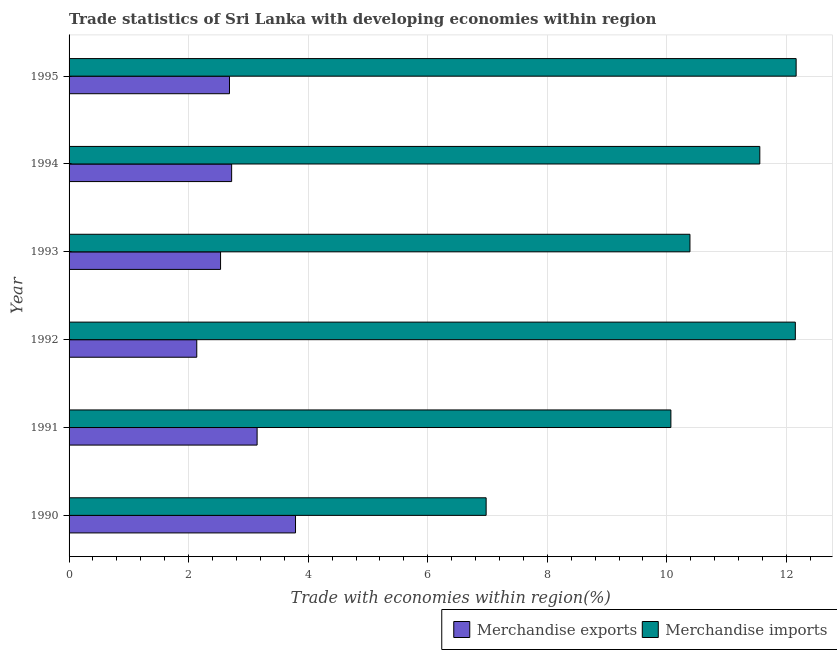How many different coloured bars are there?
Your response must be concise. 2. Are the number of bars per tick equal to the number of legend labels?
Ensure brevity in your answer.  Yes. How many bars are there on the 1st tick from the bottom?
Ensure brevity in your answer.  2. In how many cases, is the number of bars for a given year not equal to the number of legend labels?
Ensure brevity in your answer.  0. What is the merchandise imports in 1991?
Your answer should be compact. 10.07. Across all years, what is the maximum merchandise exports?
Offer a very short reply. 3.79. Across all years, what is the minimum merchandise exports?
Provide a succinct answer. 2.14. In which year was the merchandise exports maximum?
Your answer should be compact. 1990. What is the total merchandise exports in the graph?
Your answer should be very brief. 17.01. What is the difference between the merchandise imports in 1994 and that in 1995?
Your answer should be very brief. -0.61. What is the difference between the merchandise exports in 1992 and the merchandise imports in 1995?
Ensure brevity in your answer.  -10.03. What is the average merchandise exports per year?
Offer a terse response. 2.83. In the year 1993, what is the difference between the merchandise exports and merchandise imports?
Your answer should be very brief. -7.85. In how many years, is the merchandise imports greater than 7.6 %?
Your answer should be very brief. 5. What is the ratio of the merchandise exports in 1990 to that in 1993?
Your response must be concise. 1.5. Is the difference between the merchandise exports in 1990 and 1994 greater than the difference between the merchandise imports in 1990 and 1994?
Offer a very short reply. Yes. What is the difference between the highest and the second highest merchandise exports?
Provide a succinct answer. 0.64. What is the difference between the highest and the lowest merchandise exports?
Keep it short and to the point. 1.65. What does the 2nd bar from the top in 1992 represents?
Your answer should be compact. Merchandise exports. What does the 2nd bar from the bottom in 1992 represents?
Give a very brief answer. Merchandise imports. Are all the bars in the graph horizontal?
Offer a very short reply. Yes. Does the graph contain any zero values?
Your answer should be very brief. No. Does the graph contain grids?
Offer a very short reply. Yes. How many legend labels are there?
Your response must be concise. 2. How are the legend labels stacked?
Offer a terse response. Horizontal. What is the title of the graph?
Provide a succinct answer. Trade statistics of Sri Lanka with developing economies within region. What is the label or title of the X-axis?
Keep it short and to the point. Trade with economies within region(%). What is the Trade with economies within region(%) of Merchandise exports in 1990?
Your answer should be compact. 3.79. What is the Trade with economies within region(%) in Merchandise imports in 1990?
Provide a short and direct response. 6.98. What is the Trade with economies within region(%) in Merchandise exports in 1991?
Provide a short and direct response. 3.15. What is the Trade with economies within region(%) of Merchandise imports in 1991?
Offer a very short reply. 10.07. What is the Trade with economies within region(%) of Merchandise exports in 1992?
Ensure brevity in your answer.  2.14. What is the Trade with economies within region(%) of Merchandise imports in 1992?
Your answer should be compact. 12.15. What is the Trade with economies within region(%) of Merchandise exports in 1993?
Give a very brief answer. 2.53. What is the Trade with economies within region(%) of Merchandise imports in 1993?
Your answer should be compact. 10.39. What is the Trade with economies within region(%) in Merchandise exports in 1994?
Your answer should be compact. 2.72. What is the Trade with economies within region(%) of Merchandise imports in 1994?
Make the answer very short. 11.55. What is the Trade with economies within region(%) of Merchandise exports in 1995?
Provide a short and direct response. 2.68. What is the Trade with economies within region(%) of Merchandise imports in 1995?
Offer a terse response. 12.16. Across all years, what is the maximum Trade with economies within region(%) in Merchandise exports?
Provide a succinct answer. 3.79. Across all years, what is the maximum Trade with economies within region(%) in Merchandise imports?
Your response must be concise. 12.16. Across all years, what is the minimum Trade with economies within region(%) in Merchandise exports?
Give a very brief answer. 2.14. Across all years, what is the minimum Trade with economies within region(%) in Merchandise imports?
Provide a succinct answer. 6.98. What is the total Trade with economies within region(%) of Merchandise exports in the graph?
Make the answer very short. 17.01. What is the total Trade with economies within region(%) of Merchandise imports in the graph?
Provide a succinct answer. 63.3. What is the difference between the Trade with economies within region(%) in Merchandise exports in 1990 and that in 1991?
Your response must be concise. 0.64. What is the difference between the Trade with economies within region(%) in Merchandise imports in 1990 and that in 1991?
Keep it short and to the point. -3.09. What is the difference between the Trade with economies within region(%) of Merchandise exports in 1990 and that in 1992?
Ensure brevity in your answer.  1.65. What is the difference between the Trade with economies within region(%) in Merchandise imports in 1990 and that in 1992?
Your answer should be very brief. -5.17. What is the difference between the Trade with economies within region(%) in Merchandise exports in 1990 and that in 1993?
Ensure brevity in your answer.  1.25. What is the difference between the Trade with economies within region(%) in Merchandise imports in 1990 and that in 1993?
Offer a very short reply. -3.41. What is the difference between the Trade with economies within region(%) of Merchandise exports in 1990 and that in 1994?
Your answer should be very brief. 1.07. What is the difference between the Trade with economies within region(%) of Merchandise imports in 1990 and that in 1994?
Offer a terse response. -4.58. What is the difference between the Trade with economies within region(%) of Merchandise exports in 1990 and that in 1995?
Offer a terse response. 1.1. What is the difference between the Trade with economies within region(%) of Merchandise imports in 1990 and that in 1995?
Offer a very short reply. -5.19. What is the difference between the Trade with economies within region(%) in Merchandise exports in 1991 and that in 1992?
Offer a terse response. 1.01. What is the difference between the Trade with economies within region(%) of Merchandise imports in 1991 and that in 1992?
Provide a succinct answer. -2.08. What is the difference between the Trade with economies within region(%) of Merchandise exports in 1991 and that in 1993?
Offer a terse response. 0.61. What is the difference between the Trade with economies within region(%) of Merchandise imports in 1991 and that in 1993?
Your response must be concise. -0.32. What is the difference between the Trade with economies within region(%) in Merchandise exports in 1991 and that in 1994?
Your response must be concise. 0.43. What is the difference between the Trade with economies within region(%) in Merchandise imports in 1991 and that in 1994?
Keep it short and to the point. -1.49. What is the difference between the Trade with economies within region(%) in Merchandise exports in 1991 and that in 1995?
Your answer should be compact. 0.46. What is the difference between the Trade with economies within region(%) of Merchandise imports in 1991 and that in 1995?
Your answer should be very brief. -2.1. What is the difference between the Trade with economies within region(%) in Merchandise exports in 1992 and that in 1993?
Your answer should be compact. -0.4. What is the difference between the Trade with economies within region(%) in Merchandise imports in 1992 and that in 1993?
Make the answer very short. 1.76. What is the difference between the Trade with economies within region(%) in Merchandise exports in 1992 and that in 1994?
Ensure brevity in your answer.  -0.58. What is the difference between the Trade with economies within region(%) in Merchandise imports in 1992 and that in 1994?
Provide a succinct answer. 0.59. What is the difference between the Trade with economies within region(%) in Merchandise exports in 1992 and that in 1995?
Your response must be concise. -0.55. What is the difference between the Trade with economies within region(%) of Merchandise imports in 1992 and that in 1995?
Make the answer very short. -0.01. What is the difference between the Trade with economies within region(%) of Merchandise exports in 1993 and that in 1994?
Give a very brief answer. -0.19. What is the difference between the Trade with economies within region(%) in Merchandise imports in 1993 and that in 1994?
Your response must be concise. -1.17. What is the difference between the Trade with economies within region(%) in Merchandise exports in 1993 and that in 1995?
Offer a very short reply. -0.15. What is the difference between the Trade with economies within region(%) of Merchandise imports in 1993 and that in 1995?
Make the answer very short. -1.78. What is the difference between the Trade with economies within region(%) in Merchandise exports in 1994 and that in 1995?
Offer a very short reply. 0.04. What is the difference between the Trade with economies within region(%) in Merchandise imports in 1994 and that in 1995?
Ensure brevity in your answer.  -0.61. What is the difference between the Trade with economies within region(%) of Merchandise exports in 1990 and the Trade with economies within region(%) of Merchandise imports in 1991?
Offer a very short reply. -6.28. What is the difference between the Trade with economies within region(%) in Merchandise exports in 1990 and the Trade with economies within region(%) in Merchandise imports in 1992?
Give a very brief answer. -8.36. What is the difference between the Trade with economies within region(%) of Merchandise exports in 1990 and the Trade with economies within region(%) of Merchandise imports in 1993?
Provide a short and direct response. -6.6. What is the difference between the Trade with economies within region(%) in Merchandise exports in 1990 and the Trade with economies within region(%) in Merchandise imports in 1994?
Give a very brief answer. -7.77. What is the difference between the Trade with economies within region(%) of Merchandise exports in 1990 and the Trade with economies within region(%) of Merchandise imports in 1995?
Your answer should be very brief. -8.37. What is the difference between the Trade with economies within region(%) of Merchandise exports in 1991 and the Trade with economies within region(%) of Merchandise imports in 1992?
Ensure brevity in your answer.  -9. What is the difference between the Trade with economies within region(%) of Merchandise exports in 1991 and the Trade with economies within region(%) of Merchandise imports in 1993?
Ensure brevity in your answer.  -7.24. What is the difference between the Trade with economies within region(%) in Merchandise exports in 1991 and the Trade with economies within region(%) in Merchandise imports in 1994?
Offer a terse response. -8.41. What is the difference between the Trade with economies within region(%) of Merchandise exports in 1991 and the Trade with economies within region(%) of Merchandise imports in 1995?
Offer a terse response. -9.02. What is the difference between the Trade with economies within region(%) in Merchandise exports in 1992 and the Trade with economies within region(%) in Merchandise imports in 1993?
Your answer should be compact. -8.25. What is the difference between the Trade with economies within region(%) of Merchandise exports in 1992 and the Trade with economies within region(%) of Merchandise imports in 1994?
Make the answer very short. -9.42. What is the difference between the Trade with economies within region(%) in Merchandise exports in 1992 and the Trade with economies within region(%) in Merchandise imports in 1995?
Offer a very short reply. -10.03. What is the difference between the Trade with economies within region(%) of Merchandise exports in 1993 and the Trade with economies within region(%) of Merchandise imports in 1994?
Your response must be concise. -9.02. What is the difference between the Trade with economies within region(%) of Merchandise exports in 1993 and the Trade with economies within region(%) of Merchandise imports in 1995?
Offer a very short reply. -9.63. What is the difference between the Trade with economies within region(%) in Merchandise exports in 1994 and the Trade with economies within region(%) in Merchandise imports in 1995?
Keep it short and to the point. -9.44. What is the average Trade with economies within region(%) in Merchandise exports per year?
Make the answer very short. 2.83. What is the average Trade with economies within region(%) in Merchandise imports per year?
Offer a terse response. 10.55. In the year 1990, what is the difference between the Trade with economies within region(%) of Merchandise exports and Trade with economies within region(%) of Merchandise imports?
Your response must be concise. -3.19. In the year 1991, what is the difference between the Trade with economies within region(%) of Merchandise exports and Trade with economies within region(%) of Merchandise imports?
Make the answer very short. -6.92. In the year 1992, what is the difference between the Trade with economies within region(%) in Merchandise exports and Trade with economies within region(%) in Merchandise imports?
Provide a short and direct response. -10.01. In the year 1993, what is the difference between the Trade with economies within region(%) of Merchandise exports and Trade with economies within region(%) of Merchandise imports?
Ensure brevity in your answer.  -7.85. In the year 1994, what is the difference between the Trade with economies within region(%) in Merchandise exports and Trade with economies within region(%) in Merchandise imports?
Ensure brevity in your answer.  -8.84. In the year 1995, what is the difference between the Trade with economies within region(%) in Merchandise exports and Trade with economies within region(%) in Merchandise imports?
Give a very brief answer. -9.48. What is the ratio of the Trade with economies within region(%) in Merchandise exports in 1990 to that in 1991?
Make the answer very short. 1.2. What is the ratio of the Trade with economies within region(%) of Merchandise imports in 1990 to that in 1991?
Keep it short and to the point. 0.69. What is the ratio of the Trade with economies within region(%) in Merchandise exports in 1990 to that in 1992?
Offer a terse response. 1.77. What is the ratio of the Trade with economies within region(%) in Merchandise imports in 1990 to that in 1992?
Keep it short and to the point. 0.57. What is the ratio of the Trade with economies within region(%) of Merchandise exports in 1990 to that in 1993?
Your answer should be very brief. 1.49. What is the ratio of the Trade with economies within region(%) in Merchandise imports in 1990 to that in 1993?
Provide a succinct answer. 0.67. What is the ratio of the Trade with economies within region(%) in Merchandise exports in 1990 to that in 1994?
Offer a very short reply. 1.39. What is the ratio of the Trade with economies within region(%) in Merchandise imports in 1990 to that in 1994?
Your response must be concise. 0.6. What is the ratio of the Trade with economies within region(%) of Merchandise exports in 1990 to that in 1995?
Ensure brevity in your answer.  1.41. What is the ratio of the Trade with economies within region(%) in Merchandise imports in 1990 to that in 1995?
Make the answer very short. 0.57. What is the ratio of the Trade with economies within region(%) of Merchandise exports in 1991 to that in 1992?
Ensure brevity in your answer.  1.47. What is the ratio of the Trade with economies within region(%) in Merchandise imports in 1991 to that in 1992?
Your answer should be very brief. 0.83. What is the ratio of the Trade with economies within region(%) in Merchandise exports in 1991 to that in 1993?
Offer a very short reply. 1.24. What is the ratio of the Trade with economies within region(%) of Merchandise imports in 1991 to that in 1993?
Offer a very short reply. 0.97. What is the ratio of the Trade with economies within region(%) in Merchandise exports in 1991 to that in 1994?
Your answer should be very brief. 1.16. What is the ratio of the Trade with economies within region(%) in Merchandise imports in 1991 to that in 1994?
Make the answer very short. 0.87. What is the ratio of the Trade with economies within region(%) of Merchandise exports in 1991 to that in 1995?
Make the answer very short. 1.17. What is the ratio of the Trade with economies within region(%) in Merchandise imports in 1991 to that in 1995?
Make the answer very short. 0.83. What is the ratio of the Trade with economies within region(%) of Merchandise exports in 1992 to that in 1993?
Ensure brevity in your answer.  0.84. What is the ratio of the Trade with economies within region(%) of Merchandise imports in 1992 to that in 1993?
Your answer should be very brief. 1.17. What is the ratio of the Trade with economies within region(%) of Merchandise exports in 1992 to that in 1994?
Provide a succinct answer. 0.79. What is the ratio of the Trade with economies within region(%) in Merchandise imports in 1992 to that in 1994?
Your response must be concise. 1.05. What is the ratio of the Trade with economies within region(%) in Merchandise exports in 1992 to that in 1995?
Offer a terse response. 0.8. What is the ratio of the Trade with economies within region(%) of Merchandise imports in 1992 to that in 1995?
Your answer should be compact. 1. What is the ratio of the Trade with economies within region(%) of Merchandise exports in 1993 to that in 1994?
Your response must be concise. 0.93. What is the ratio of the Trade with economies within region(%) in Merchandise imports in 1993 to that in 1994?
Your answer should be compact. 0.9. What is the ratio of the Trade with economies within region(%) in Merchandise imports in 1993 to that in 1995?
Your answer should be compact. 0.85. What is the ratio of the Trade with economies within region(%) of Merchandise exports in 1994 to that in 1995?
Provide a short and direct response. 1.01. What is the difference between the highest and the second highest Trade with economies within region(%) in Merchandise exports?
Provide a succinct answer. 0.64. What is the difference between the highest and the second highest Trade with economies within region(%) of Merchandise imports?
Provide a short and direct response. 0.01. What is the difference between the highest and the lowest Trade with economies within region(%) in Merchandise exports?
Provide a succinct answer. 1.65. What is the difference between the highest and the lowest Trade with economies within region(%) of Merchandise imports?
Offer a terse response. 5.19. 